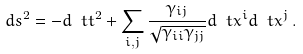Convert formula to latex. <formula><loc_0><loc_0><loc_500><loc_500>d s ^ { 2 } = - d \ t { t } ^ { 2 } + \sum _ { i , j } \frac { \gamma _ { i j } } { \sqrt { \gamma _ { i i } \gamma _ { j j } } } d \ t { x } ^ { i } d \ t { x } ^ { j } \, .</formula> 